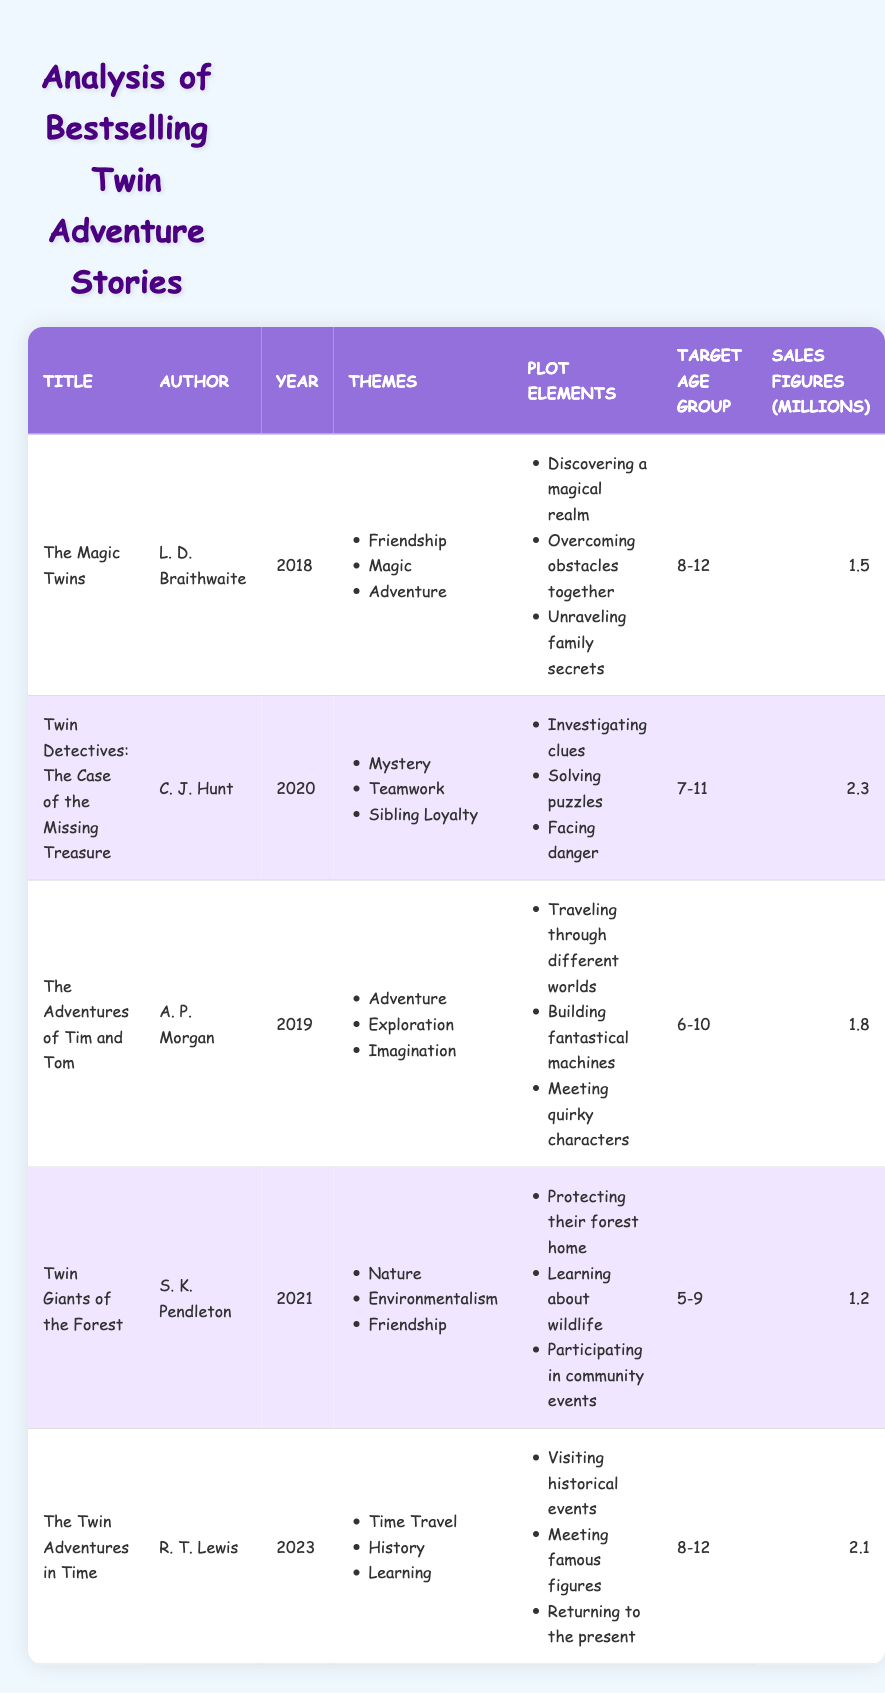What is the title of the book written by R. T. Lewis? The table lists the books along with their authors and other details. By searching for R. T. Lewis in the Author column, we find that the title associated with this author is "The Twin Adventures in Time."
Answer: The Twin Adventures in Time Which book has the highest sales figures? To find the highest sales figures, we compare the values in the Sales Figures column. The highest value is 2.3 million for "Twin Detectives: The Case of the Missing Treasure."
Answer: Twin Detectives: The Case of the Missing Treasure What themes are present in "The Magic Twins"? The Themes column lists the themes associated with each book. For "The Magic Twins," the relevant themes are Friendship, Magic, and Adventure.
Answer: Friendship, Magic, Adventure How many books listed are targeted at the age group of 8-12? We check the Target Age Group column for the range of 8-12 and count the occurrences. The books with this age group are "The Magic Twins," "The Twin Adventures in Time," giving us a total of 2 books.
Answer: 2 What is the average sales figure for the books in the table? We sum the sales figures: 1.5 + 2.3 + 1.8 + 1.2 + 2.1 = 10.9 million for 5 books. To get the average, we divide the total sales by the number of books: 10.9 / 5 = 2.18 million.
Answer: 2.18 million Do all books feature the theme of adventure? We need to check the Themes column for all books to see if "Adventure" is listed in each. The books that do have this theme are "The Magic Twins," "The Adventures of Tim and Tom," and "The Twin Adventures in Time." However, "Twin Detectives: The Case of the Missing Treasure" and "Twin Giants of the Forest" do not have this theme. Thus, the statement is false.
Answer: No Which book published in 2021 has the theme of nature? We look in the Year column for 2021, where we find "Twin Giants of the Forest." We then check the Themes column for this book, confirming it includes "Nature" as one of its themes.
Answer: Twin Giants of the Forest How many different themes are featured across all books? To find the different themes, we can list all unique themes from the Themes column: Friendship, Magic, Adventure, Mystery, Teamwork, Sibling Loyalty, Exploration, Imagination, Nature, Environmentalism, Time Travel, History, Learning. Counting these gives us 13 unique themes.
Answer: 13 What plot element is common in "Twin Detectives: The Case of the Missing Treasure" and "The Twin Adventures in Time"? We compare the Plot Elements for both books. For "Twin Detectives," the elements are Investigating clues, Solving puzzles, and Facing danger. For "The Twin Adventures in Time," the elements are Visiting historical events, Meeting famous figures, Returning to the present. There is no overlap in plot elements, making this statement false.
Answer: No common plot element 